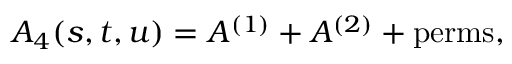Convert formula to latex. <formula><loc_0><loc_0><loc_500><loc_500>A _ { 4 } ( s , t , u ) = A ^ { ( 1 ) } + A ^ { ( 2 ) } + p e r m s ,</formula> 